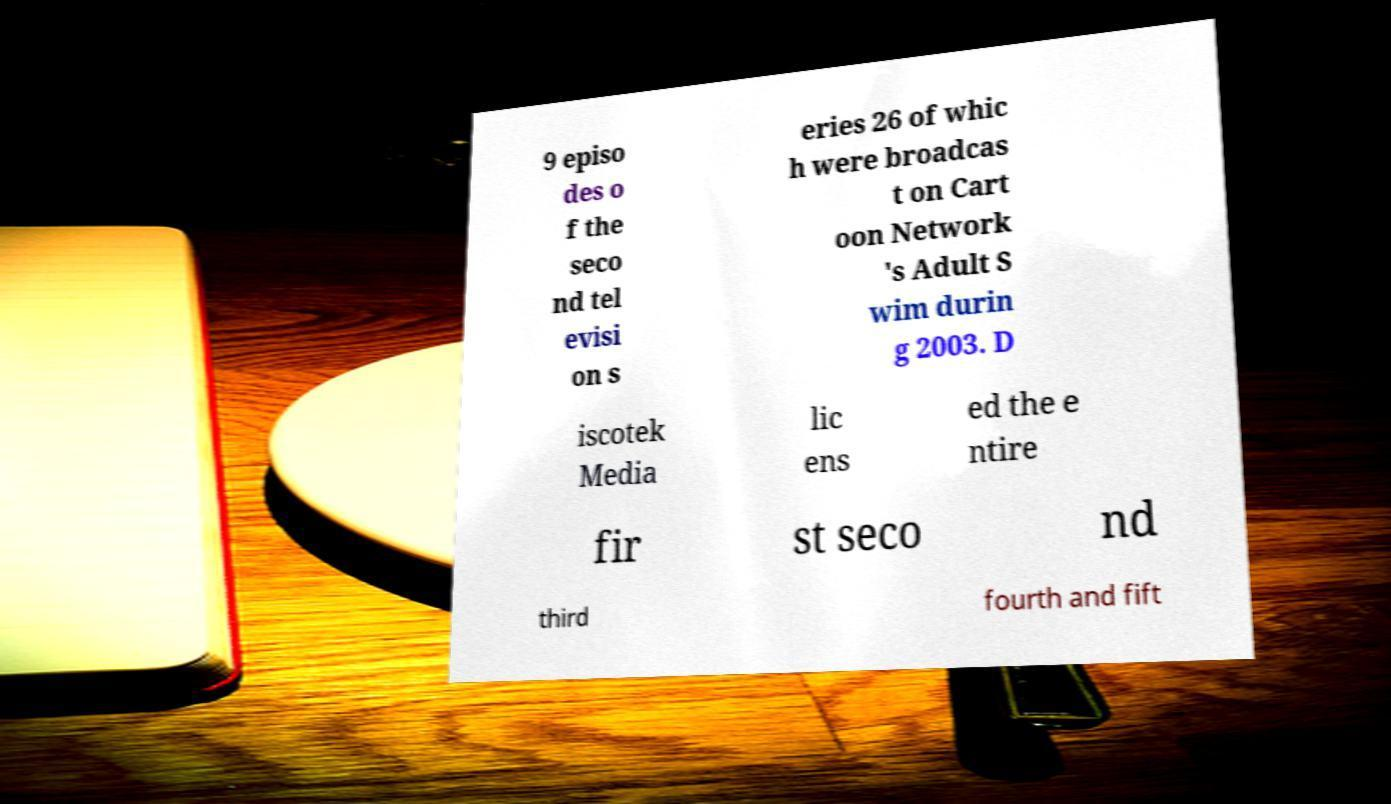What messages or text are displayed in this image? I need them in a readable, typed format. 9 episo des o f the seco nd tel evisi on s eries 26 of whic h were broadcas t on Cart oon Network 's Adult S wim durin g 2003. D iscotek Media lic ens ed the e ntire fir st seco nd third fourth and fift 